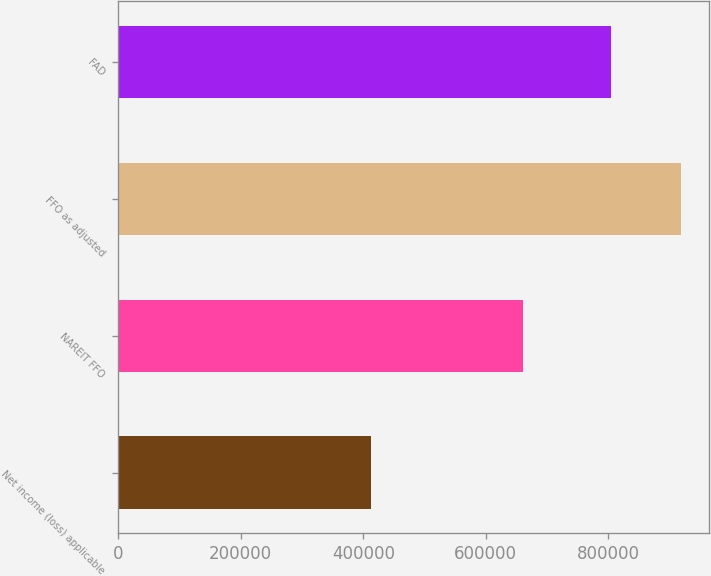Convert chart. <chart><loc_0><loc_0><loc_500><loc_500><bar_chart><fcel>Net income (loss) applicable<fcel>NAREIT FFO<fcel>FFO as adjusted<fcel>FAD<nl><fcel>413013<fcel>661113<fcel>918402<fcel>803720<nl></chart> 